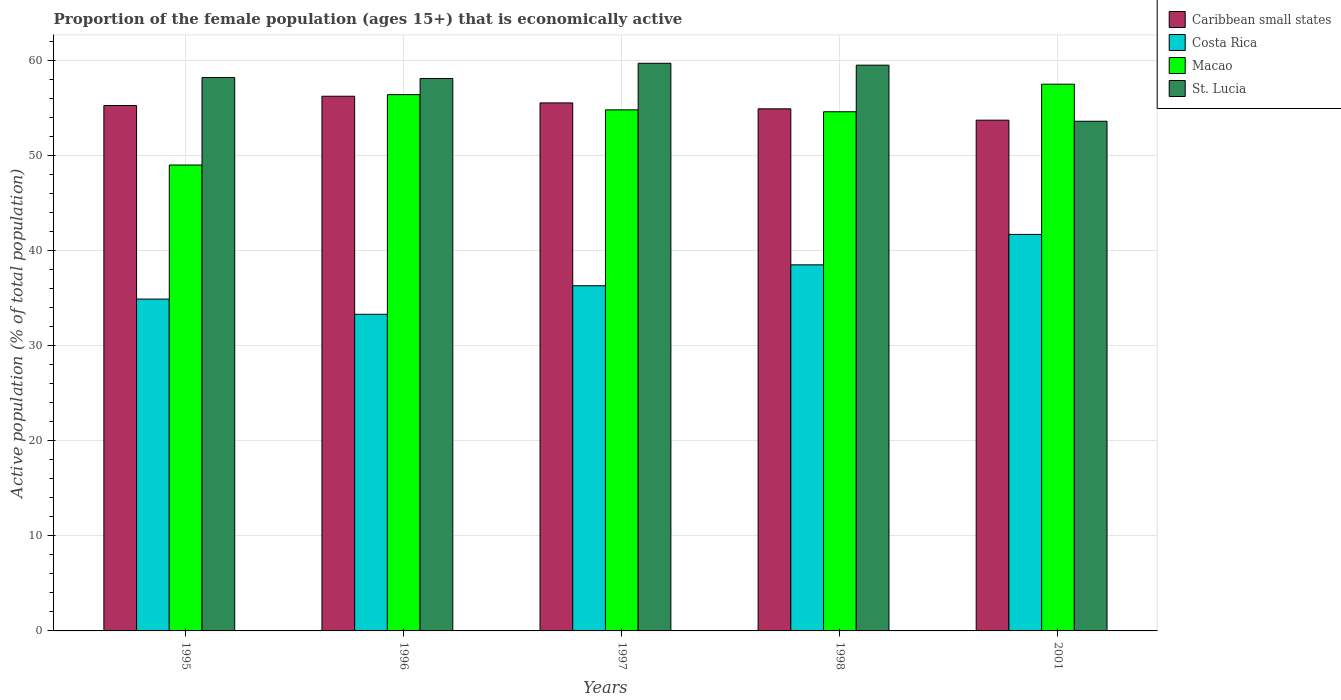How many different coloured bars are there?
Ensure brevity in your answer.  4. How many bars are there on the 2nd tick from the right?
Provide a short and direct response. 4. What is the label of the 1st group of bars from the left?
Provide a short and direct response. 1995. In how many cases, is the number of bars for a given year not equal to the number of legend labels?
Provide a succinct answer. 0. What is the proportion of the female population that is economically active in Macao in 2001?
Ensure brevity in your answer.  57.5. Across all years, what is the maximum proportion of the female population that is economically active in Caribbean small states?
Make the answer very short. 56.23. Across all years, what is the minimum proportion of the female population that is economically active in St. Lucia?
Provide a short and direct response. 53.6. What is the total proportion of the female population that is economically active in St. Lucia in the graph?
Make the answer very short. 289.1. What is the difference between the proportion of the female population that is economically active in St. Lucia in 1995 and that in 2001?
Give a very brief answer. 4.6. What is the difference between the proportion of the female population that is economically active in Caribbean small states in 1996 and the proportion of the female population that is economically active in Macao in 1995?
Provide a succinct answer. 7.23. What is the average proportion of the female population that is economically active in Caribbean small states per year?
Provide a short and direct response. 55.13. In the year 2001, what is the difference between the proportion of the female population that is economically active in Macao and proportion of the female population that is economically active in Costa Rica?
Offer a very short reply. 15.8. In how many years, is the proportion of the female population that is economically active in Costa Rica greater than 36 %?
Provide a succinct answer. 3. What is the ratio of the proportion of the female population that is economically active in St. Lucia in 1995 to that in 1998?
Your answer should be compact. 0.98. Is the difference between the proportion of the female population that is economically active in Macao in 1997 and 1998 greater than the difference between the proportion of the female population that is economically active in Costa Rica in 1997 and 1998?
Provide a succinct answer. Yes. What is the difference between the highest and the second highest proportion of the female population that is economically active in Caribbean small states?
Make the answer very short. 0.7. What is the difference between the highest and the lowest proportion of the female population that is economically active in Macao?
Provide a succinct answer. 8.5. What does the 1st bar from the left in 1995 represents?
Make the answer very short. Caribbean small states. What does the 4th bar from the right in 1995 represents?
Offer a terse response. Caribbean small states. What is the difference between two consecutive major ticks on the Y-axis?
Provide a short and direct response. 10. Are the values on the major ticks of Y-axis written in scientific E-notation?
Offer a terse response. No. Where does the legend appear in the graph?
Give a very brief answer. Top right. What is the title of the graph?
Provide a succinct answer. Proportion of the female population (ages 15+) that is economically active. Does "Brunei Darussalam" appear as one of the legend labels in the graph?
Provide a succinct answer. No. What is the label or title of the Y-axis?
Offer a very short reply. Active population (% of total population). What is the Active population (% of total population) of Caribbean small states in 1995?
Ensure brevity in your answer.  55.26. What is the Active population (% of total population) in Costa Rica in 1995?
Your answer should be compact. 34.9. What is the Active population (% of total population) of St. Lucia in 1995?
Provide a short and direct response. 58.2. What is the Active population (% of total population) in Caribbean small states in 1996?
Your answer should be compact. 56.23. What is the Active population (% of total population) of Costa Rica in 1996?
Keep it short and to the point. 33.3. What is the Active population (% of total population) of Macao in 1996?
Offer a very short reply. 56.4. What is the Active population (% of total population) in St. Lucia in 1996?
Provide a short and direct response. 58.1. What is the Active population (% of total population) of Caribbean small states in 1997?
Offer a terse response. 55.53. What is the Active population (% of total population) of Costa Rica in 1997?
Give a very brief answer. 36.3. What is the Active population (% of total population) of Macao in 1997?
Your response must be concise. 54.8. What is the Active population (% of total population) in St. Lucia in 1997?
Provide a short and direct response. 59.7. What is the Active population (% of total population) in Caribbean small states in 1998?
Offer a terse response. 54.91. What is the Active population (% of total population) in Costa Rica in 1998?
Give a very brief answer. 38.5. What is the Active population (% of total population) of Macao in 1998?
Keep it short and to the point. 54.6. What is the Active population (% of total population) in St. Lucia in 1998?
Offer a very short reply. 59.5. What is the Active population (% of total population) of Caribbean small states in 2001?
Keep it short and to the point. 53.72. What is the Active population (% of total population) in Costa Rica in 2001?
Your response must be concise. 41.7. What is the Active population (% of total population) of Macao in 2001?
Provide a short and direct response. 57.5. What is the Active population (% of total population) in St. Lucia in 2001?
Provide a succinct answer. 53.6. Across all years, what is the maximum Active population (% of total population) in Caribbean small states?
Make the answer very short. 56.23. Across all years, what is the maximum Active population (% of total population) in Costa Rica?
Provide a succinct answer. 41.7. Across all years, what is the maximum Active population (% of total population) of Macao?
Offer a terse response. 57.5. Across all years, what is the maximum Active population (% of total population) of St. Lucia?
Provide a succinct answer. 59.7. Across all years, what is the minimum Active population (% of total population) in Caribbean small states?
Give a very brief answer. 53.72. Across all years, what is the minimum Active population (% of total population) in Costa Rica?
Provide a short and direct response. 33.3. Across all years, what is the minimum Active population (% of total population) in St. Lucia?
Provide a succinct answer. 53.6. What is the total Active population (% of total population) of Caribbean small states in the graph?
Your response must be concise. 275.64. What is the total Active population (% of total population) of Costa Rica in the graph?
Ensure brevity in your answer.  184.7. What is the total Active population (% of total population) in Macao in the graph?
Your response must be concise. 272.3. What is the total Active population (% of total population) of St. Lucia in the graph?
Keep it short and to the point. 289.1. What is the difference between the Active population (% of total population) in Caribbean small states in 1995 and that in 1996?
Your answer should be very brief. -0.98. What is the difference between the Active population (% of total population) in Costa Rica in 1995 and that in 1996?
Your answer should be compact. 1.6. What is the difference between the Active population (% of total population) in Caribbean small states in 1995 and that in 1997?
Your answer should be very brief. -0.27. What is the difference between the Active population (% of total population) in Costa Rica in 1995 and that in 1997?
Your response must be concise. -1.4. What is the difference between the Active population (% of total population) of Macao in 1995 and that in 1997?
Ensure brevity in your answer.  -5.8. What is the difference between the Active population (% of total population) of St. Lucia in 1995 and that in 1997?
Offer a terse response. -1.5. What is the difference between the Active population (% of total population) in Caribbean small states in 1995 and that in 1998?
Offer a very short reply. 0.35. What is the difference between the Active population (% of total population) in Caribbean small states in 1995 and that in 2001?
Ensure brevity in your answer.  1.54. What is the difference between the Active population (% of total population) in St. Lucia in 1995 and that in 2001?
Your answer should be very brief. 4.6. What is the difference between the Active population (% of total population) in Caribbean small states in 1996 and that in 1997?
Your answer should be compact. 0.7. What is the difference between the Active population (% of total population) of Macao in 1996 and that in 1997?
Your response must be concise. 1.6. What is the difference between the Active population (% of total population) of Caribbean small states in 1996 and that in 1998?
Ensure brevity in your answer.  1.32. What is the difference between the Active population (% of total population) in St. Lucia in 1996 and that in 1998?
Offer a terse response. -1.4. What is the difference between the Active population (% of total population) in Caribbean small states in 1996 and that in 2001?
Give a very brief answer. 2.52. What is the difference between the Active population (% of total population) of Macao in 1996 and that in 2001?
Provide a short and direct response. -1.1. What is the difference between the Active population (% of total population) of Caribbean small states in 1997 and that in 1998?
Offer a very short reply. 0.62. What is the difference between the Active population (% of total population) of Caribbean small states in 1997 and that in 2001?
Your answer should be compact. 1.81. What is the difference between the Active population (% of total population) of St. Lucia in 1997 and that in 2001?
Your response must be concise. 6.1. What is the difference between the Active population (% of total population) in Caribbean small states in 1998 and that in 2001?
Your response must be concise. 1.19. What is the difference between the Active population (% of total population) in Caribbean small states in 1995 and the Active population (% of total population) in Costa Rica in 1996?
Your answer should be compact. 21.96. What is the difference between the Active population (% of total population) in Caribbean small states in 1995 and the Active population (% of total population) in Macao in 1996?
Your answer should be compact. -1.14. What is the difference between the Active population (% of total population) in Caribbean small states in 1995 and the Active population (% of total population) in St. Lucia in 1996?
Your response must be concise. -2.84. What is the difference between the Active population (% of total population) in Costa Rica in 1995 and the Active population (% of total population) in Macao in 1996?
Your response must be concise. -21.5. What is the difference between the Active population (% of total population) of Costa Rica in 1995 and the Active population (% of total population) of St. Lucia in 1996?
Your answer should be very brief. -23.2. What is the difference between the Active population (% of total population) in Macao in 1995 and the Active population (% of total population) in St. Lucia in 1996?
Your answer should be compact. -9.1. What is the difference between the Active population (% of total population) in Caribbean small states in 1995 and the Active population (% of total population) in Costa Rica in 1997?
Offer a very short reply. 18.96. What is the difference between the Active population (% of total population) in Caribbean small states in 1995 and the Active population (% of total population) in Macao in 1997?
Your answer should be compact. 0.46. What is the difference between the Active population (% of total population) of Caribbean small states in 1995 and the Active population (% of total population) of St. Lucia in 1997?
Your answer should be very brief. -4.44. What is the difference between the Active population (% of total population) in Costa Rica in 1995 and the Active population (% of total population) in Macao in 1997?
Your answer should be compact. -19.9. What is the difference between the Active population (% of total population) in Costa Rica in 1995 and the Active population (% of total population) in St. Lucia in 1997?
Offer a very short reply. -24.8. What is the difference between the Active population (% of total population) in Caribbean small states in 1995 and the Active population (% of total population) in Costa Rica in 1998?
Your response must be concise. 16.76. What is the difference between the Active population (% of total population) in Caribbean small states in 1995 and the Active population (% of total population) in Macao in 1998?
Keep it short and to the point. 0.66. What is the difference between the Active population (% of total population) of Caribbean small states in 1995 and the Active population (% of total population) of St. Lucia in 1998?
Your answer should be very brief. -4.24. What is the difference between the Active population (% of total population) in Costa Rica in 1995 and the Active population (% of total population) in Macao in 1998?
Provide a short and direct response. -19.7. What is the difference between the Active population (% of total population) in Costa Rica in 1995 and the Active population (% of total population) in St. Lucia in 1998?
Make the answer very short. -24.6. What is the difference between the Active population (% of total population) of Macao in 1995 and the Active population (% of total population) of St. Lucia in 1998?
Offer a terse response. -10.5. What is the difference between the Active population (% of total population) of Caribbean small states in 1995 and the Active population (% of total population) of Costa Rica in 2001?
Provide a succinct answer. 13.56. What is the difference between the Active population (% of total population) of Caribbean small states in 1995 and the Active population (% of total population) of Macao in 2001?
Provide a succinct answer. -2.24. What is the difference between the Active population (% of total population) in Caribbean small states in 1995 and the Active population (% of total population) in St. Lucia in 2001?
Your answer should be very brief. 1.66. What is the difference between the Active population (% of total population) in Costa Rica in 1995 and the Active population (% of total population) in Macao in 2001?
Your answer should be very brief. -22.6. What is the difference between the Active population (% of total population) in Costa Rica in 1995 and the Active population (% of total population) in St. Lucia in 2001?
Provide a succinct answer. -18.7. What is the difference between the Active population (% of total population) of Macao in 1995 and the Active population (% of total population) of St. Lucia in 2001?
Your answer should be compact. -4.6. What is the difference between the Active population (% of total population) in Caribbean small states in 1996 and the Active population (% of total population) in Costa Rica in 1997?
Make the answer very short. 19.93. What is the difference between the Active population (% of total population) of Caribbean small states in 1996 and the Active population (% of total population) of Macao in 1997?
Your answer should be very brief. 1.43. What is the difference between the Active population (% of total population) in Caribbean small states in 1996 and the Active population (% of total population) in St. Lucia in 1997?
Provide a succinct answer. -3.47. What is the difference between the Active population (% of total population) of Costa Rica in 1996 and the Active population (% of total population) of Macao in 1997?
Provide a succinct answer. -21.5. What is the difference between the Active population (% of total population) of Costa Rica in 1996 and the Active population (% of total population) of St. Lucia in 1997?
Provide a succinct answer. -26.4. What is the difference between the Active population (% of total population) of Macao in 1996 and the Active population (% of total population) of St. Lucia in 1997?
Provide a short and direct response. -3.3. What is the difference between the Active population (% of total population) of Caribbean small states in 1996 and the Active population (% of total population) of Costa Rica in 1998?
Your answer should be compact. 17.73. What is the difference between the Active population (% of total population) of Caribbean small states in 1996 and the Active population (% of total population) of Macao in 1998?
Your response must be concise. 1.63. What is the difference between the Active population (% of total population) of Caribbean small states in 1996 and the Active population (% of total population) of St. Lucia in 1998?
Provide a short and direct response. -3.27. What is the difference between the Active population (% of total population) in Costa Rica in 1996 and the Active population (% of total population) in Macao in 1998?
Your answer should be very brief. -21.3. What is the difference between the Active population (% of total population) in Costa Rica in 1996 and the Active population (% of total population) in St. Lucia in 1998?
Offer a very short reply. -26.2. What is the difference between the Active population (% of total population) of Macao in 1996 and the Active population (% of total population) of St. Lucia in 1998?
Ensure brevity in your answer.  -3.1. What is the difference between the Active population (% of total population) in Caribbean small states in 1996 and the Active population (% of total population) in Costa Rica in 2001?
Provide a short and direct response. 14.53. What is the difference between the Active population (% of total population) in Caribbean small states in 1996 and the Active population (% of total population) in Macao in 2001?
Your answer should be very brief. -1.27. What is the difference between the Active population (% of total population) in Caribbean small states in 1996 and the Active population (% of total population) in St. Lucia in 2001?
Your answer should be compact. 2.63. What is the difference between the Active population (% of total population) in Costa Rica in 1996 and the Active population (% of total population) in Macao in 2001?
Offer a very short reply. -24.2. What is the difference between the Active population (% of total population) of Costa Rica in 1996 and the Active population (% of total population) of St. Lucia in 2001?
Make the answer very short. -20.3. What is the difference between the Active population (% of total population) of Caribbean small states in 1997 and the Active population (% of total population) of Costa Rica in 1998?
Provide a succinct answer. 17.03. What is the difference between the Active population (% of total population) in Caribbean small states in 1997 and the Active population (% of total population) in Macao in 1998?
Make the answer very short. 0.93. What is the difference between the Active population (% of total population) in Caribbean small states in 1997 and the Active population (% of total population) in St. Lucia in 1998?
Offer a terse response. -3.97. What is the difference between the Active population (% of total population) of Costa Rica in 1997 and the Active population (% of total population) of Macao in 1998?
Your answer should be compact. -18.3. What is the difference between the Active population (% of total population) in Costa Rica in 1997 and the Active population (% of total population) in St. Lucia in 1998?
Ensure brevity in your answer.  -23.2. What is the difference between the Active population (% of total population) of Macao in 1997 and the Active population (% of total population) of St. Lucia in 1998?
Your answer should be very brief. -4.7. What is the difference between the Active population (% of total population) in Caribbean small states in 1997 and the Active population (% of total population) in Costa Rica in 2001?
Your answer should be very brief. 13.83. What is the difference between the Active population (% of total population) in Caribbean small states in 1997 and the Active population (% of total population) in Macao in 2001?
Your response must be concise. -1.97. What is the difference between the Active population (% of total population) in Caribbean small states in 1997 and the Active population (% of total population) in St. Lucia in 2001?
Ensure brevity in your answer.  1.93. What is the difference between the Active population (% of total population) in Costa Rica in 1997 and the Active population (% of total population) in Macao in 2001?
Keep it short and to the point. -21.2. What is the difference between the Active population (% of total population) of Costa Rica in 1997 and the Active population (% of total population) of St. Lucia in 2001?
Offer a very short reply. -17.3. What is the difference between the Active population (% of total population) of Caribbean small states in 1998 and the Active population (% of total population) of Costa Rica in 2001?
Offer a very short reply. 13.21. What is the difference between the Active population (% of total population) of Caribbean small states in 1998 and the Active population (% of total population) of Macao in 2001?
Provide a short and direct response. -2.59. What is the difference between the Active population (% of total population) in Caribbean small states in 1998 and the Active population (% of total population) in St. Lucia in 2001?
Your answer should be compact. 1.31. What is the difference between the Active population (% of total population) in Costa Rica in 1998 and the Active population (% of total population) in Macao in 2001?
Your response must be concise. -19. What is the difference between the Active population (% of total population) in Costa Rica in 1998 and the Active population (% of total population) in St. Lucia in 2001?
Give a very brief answer. -15.1. What is the average Active population (% of total population) of Caribbean small states per year?
Keep it short and to the point. 55.13. What is the average Active population (% of total population) of Costa Rica per year?
Provide a short and direct response. 36.94. What is the average Active population (% of total population) of Macao per year?
Offer a very short reply. 54.46. What is the average Active population (% of total population) in St. Lucia per year?
Offer a terse response. 57.82. In the year 1995, what is the difference between the Active population (% of total population) of Caribbean small states and Active population (% of total population) of Costa Rica?
Offer a very short reply. 20.36. In the year 1995, what is the difference between the Active population (% of total population) of Caribbean small states and Active population (% of total population) of Macao?
Make the answer very short. 6.26. In the year 1995, what is the difference between the Active population (% of total population) of Caribbean small states and Active population (% of total population) of St. Lucia?
Provide a succinct answer. -2.94. In the year 1995, what is the difference between the Active population (% of total population) in Costa Rica and Active population (% of total population) in Macao?
Offer a terse response. -14.1. In the year 1995, what is the difference between the Active population (% of total population) of Costa Rica and Active population (% of total population) of St. Lucia?
Your response must be concise. -23.3. In the year 1996, what is the difference between the Active population (% of total population) of Caribbean small states and Active population (% of total population) of Costa Rica?
Provide a succinct answer. 22.93. In the year 1996, what is the difference between the Active population (% of total population) in Caribbean small states and Active population (% of total population) in Macao?
Offer a very short reply. -0.17. In the year 1996, what is the difference between the Active population (% of total population) in Caribbean small states and Active population (% of total population) in St. Lucia?
Provide a short and direct response. -1.87. In the year 1996, what is the difference between the Active population (% of total population) in Costa Rica and Active population (% of total population) in Macao?
Make the answer very short. -23.1. In the year 1996, what is the difference between the Active population (% of total population) of Costa Rica and Active population (% of total population) of St. Lucia?
Ensure brevity in your answer.  -24.8. In the year 1997, what is the difference between the Active population (% of total population) in Caribbean small states and Active population (% of total population) in Costa Rica?
Keep it short and to the point. 19.23. In the year 1997, what is the difference between the Active population (% of total population) in Caribbean small states and Active population (% of total population) in Macao?
Offer a very short reply. 0.73. In the year 1997, what is the difference between the Active population (% of total population) in Caribbean small states and Active population (% of total population) in St. Lucia?
Keep it short and to the point. -4.17. In the year 1997, what is the difference between the Active population (% of total population) of Costa Rica and Active population (% of total population) of Macao?
Ensure brevity in your answer.  -18.5. In the year 1997, what is the difference between the Active population (% of total population) of Costa Rica and Active population (% of total population) of St. Lucia?
Your answer should be compact. -23.4. In the year 1997, what is the difference between the Active population (% of total population) of Macao and Active population (% of total population) of St. Lucia?
Provide a short and direct response. -4.9. In the year 1998, what is the difference between the Active population (% of total population) of Caribbean small states and Active population (% of total population) of Costa Rica?
Ensure brevity in your answer.  16.41. In the year 1998, what is the difference between the Active population (% of total population) of Caribbean small states and Active population (% of total population) of Macao?
Your response must be concise. 0.31. In the year 1998, what is the difference between the Active population (% of total population) of Caribbean small states and Active population (% of total population) of St. Lucia?
Ensure brevity in your answer.  -4.59. In the year 1998, what is the difference between the Active population (% of total population) in Costa Rica and Active population (% of total population) in Macao?
Make the answer very short. -16.1. In the year 1998, what is the difference between the Active population (% of total population) of Costa Rica and Active population (% of total population) of St. Lucia?
Keep it short and to the point. -21. In the year 1998, what is the difference between the Active population (% of total population) in Macao and Active population (% of total population) in St. Lucia?
Give a very brief answer. -4.9. In the year 2001, what is the difference between the Active population (% of total population) of Caribbean small states and Active population (% of total population) of Costa Rica?
Offer a very short reply. 12.02. In the year 2001, what is the difference between the Active population (% of total population) of Caribbean small states and Active population (% of total population) of Macao?
Your response must be concise. -3.79. In the year 2001, what is the difference between the Active population (% of total population) of Caribbean small states and Active population (% of total population) of St. Lucia?
Your answer should be compact. 0.12. In the year 2001, what is the difference between the Active population (% of total population) of Costa Rica and Active population (% of total population) of Macao?
Provide a short and direct response. -15.8. In the year 2001, what is the difference between the Active population (% of total population) in Costa Rica and Active population (% of total population) in St. Lucia?
Your response must be concise. -11.9. What is the ratio of the Active population (% of total population) of Caribbean small states in 1995 to that in 1996?
Offer a very short reply. 0.98. What is the ratio of the Active population (% of total population) in Costa Rica in 1995 to that in 1996?
Give a very brief answer. 1.05. What is the ratio of the Active population (% of total population) in Macao in 1995 to that in 1996?
Your response must be concise. 0.87. What is the ratio of the Active population (% of total population) of St. Lucia in 1995 to that in 1996?
Provide a succinct answer. 1. What is the ratio of the Active population (% of total population) in Caribbean small states in 1995 to that in 1997?
Provide a succinct answer. 1. What is the ratio of the Active population (% of total population) of Costa Rica in 1995 to that in 1997?
Make the answer very short. 0.96. What is the ratio of the Active population (% of total population) of Macao in 1995 to that in 1997?
Offer a very short reply. 0.89. What is the ratio of the Active population (% of total population) in St. Lucia in 1995 to that in 1997?
Offer a terse response. 0.97. What is the ratio of the Active population (% of total population) of Caribbean small states in 1995 to that in 1998?
Make the answer very short. 1.01. What is the ratio of the Active population (% of total population) of Costa Rica in 1995 to that in 1998?
Offer a very short reply. 0.91. What is the ratio of the Active population (% of total population) in Macao in 1995 to that in 1998?
Keep it short and to the point. 0.9. What is the ratio of the Active population (% of total population) of St. Lucia in 1995 to that in 1998?
Provide a succinct answer. 0.98. What is the ratio of the Active population (% of total population) of Caribbean small states in 1995 to that in 2001?
Your response must be concise. 1.03. What is the ratio of the Active population (% of total population) in Costa Rica in 1995 to that in 2001?
Make the answer very short. 0.84. What is the ratio of the Active population (% of total population) in Macao in 1995 to that in 2001?
Your response must be concise. 0.85. What is the ratio of the Active population (% of total population) in St. Lucia in 1995 to that in 2001?
Make the answer very short. 1.09. What is the ratio of the Active population (% of total population) of Caribbean small states in 1996 to that in 1997?
Provide a succinct answer. 1.01. What is the ratio of the Active population (% of total population) of Costa Rica in 1996 to that in 1997?
Keep it short and to the point. 0.92. What is the ratio of the Active population (% of total population) of Macao in 1996 to that in 1997?
Give a very brief answer. 1.03. What is the ratio of the Active population (% of total population) of St. Lucia in 1996 to that in 1997?
Keep it short and to the point. 0.97. What is the ratio of the Active population (% of total population) in Caribbean small states in 1996 to that in 1998?
Provide a short and direct response. 1.02. What is the ratio of the Active population (% of total population) of Costa Rica in 1996 to that in 1998?
Provide a short and direct response. 0.86. What is the ratio of the Active population (% of total population) in Macao in 1996 to that in 1998?
Your answer should be compact. 1.03. What is the ratio of the Active population (% of total population) in St. Lucia in 1996 to that in 1998?
Keep it short and to the point. 0.98. What is the ratio of the Active population (% of total population) in Caribbean small states in 1996 to that in 2001?
Provide a short and direct response. 1.05. What is the ratio of the Active population (% of total population) of Costa Rica in 1996 to that in 2001?
Your answer should be very brief. 0.8. What is the ratio of the Active population (% of total population) in Macao in 1996 to that in 2001?
Keep it short and to the point. 0.98. What is the ratio of the Active population (% of total population) in St. Lucia in 1996 to that in 2001?
Offer a very short reply. 1.08. What is the ratio of the Active population (% of total population) of Caribbean small states in 1997 to that in 1998?
Make the answer very short. 1.01. What is the ratio of the Active population (% of total population) of Costa Rica in 1997 to that in 1998?
Offer a terse response. 0.94. What is the ratio of the Active population (% of total population) in Caribbean small states in 1997 to that in 2001?
Your answer should be very brief. 1.03. What is the ratio of the Active population (% of total population) of Costa Rica in 1997 to that in 2001?
Your answer should be very brief. 0.87. What is the ratio of the Active population (% of total population) in Macao in 1997 to that in 2001?
Offer a very short reply. 0.95. What is the ratio of the Active population (% of total population) of St. Lucia in 1997 to that in 2001?
Keep it short and to the point. 1.11. What is the ratio of the Active population (% of total population) of Caribbean small states in 1998 to that in 2001?
Make the answer very short. 1.02. What is the ratio of the Active population (% of total population) in Costa Rica in 1998 to that in 2001?
Provide a succinct answer. 0.92. What is the ratio of the Active population (% of total population) of Macao in 1998 to that in 2001?
Provide a succinct answer. 0.95. What is the ratio of the Active population (% of total population) in St. Lucia in 1998 to that in 2001?
Your answer should be very brief. 1.11. What is the difference between the highest and the second highest Active population (% of total population) in Caribbean small states?
Provide a short and direct response. 0.7. What is the difference between the highest and the second highest Active population (% of total population) in Costa Rica?
Your response must be concise. 3.2. What is the difference between the highest and the second highest Active population (% of total population) in Macao?
Your answer should be compact. 1.1. What is the difference between the highest and the lowest Active population (% of total population) in Caribbean small states?
Ensure brevity in your answer.  2.52. What is the difference between the highest and the lowest Active population (% of total population) of Macao?
Provide a succinct answer. 8.5. 